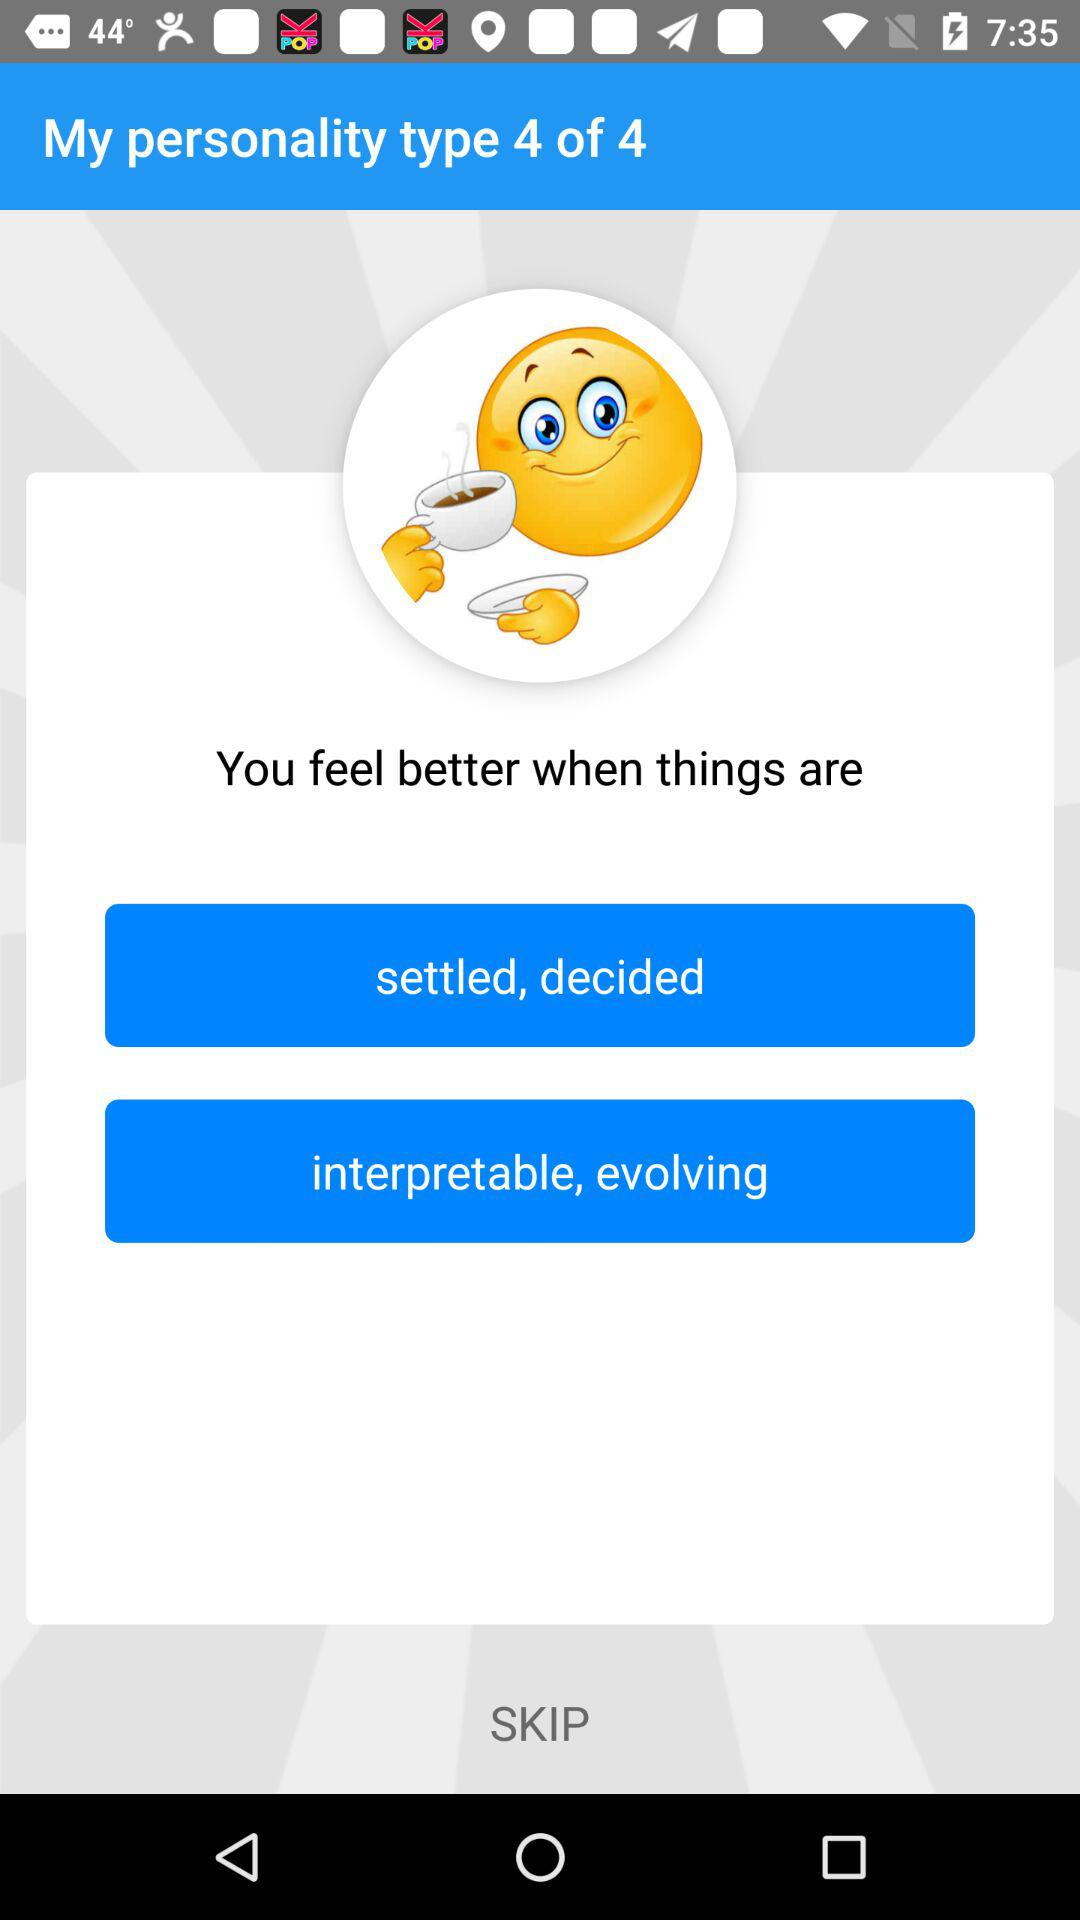What is the personality type?
When the provided information is insufficient, respond with <no answer>. <no answer> 